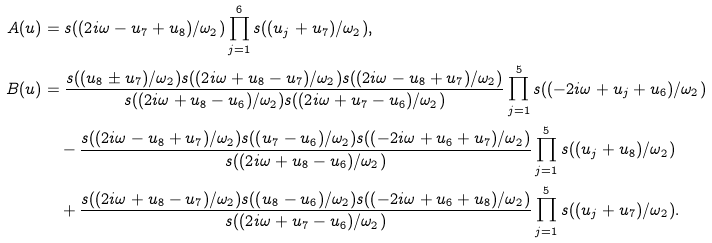Convert formula to latex. <formula><loc_0><loc_0><loc_500><loc_500>A ( u ) & = s ( ( 2 i \omega - u _ { 7 } + u _ { 8 } ) / \omega _ { 2 } ) \prod _ { j = 1 } ^ { 6 } s ( ( u _ { j } + u _ { 7 } ) / \omega _ { 2 } ) , \\ B ( u ) & = \frac { s ( ( u _ { 8 } \pm u _ { 7 } ) / \omega _ { 2 } ) s ( ( 2 i \omega + u _ { 8 } - u _ { 7 } ) / \omega _ { 2 } ) s ( ( 2 i \omega - u _ { 8 } + u _ { 7 } ) / \omega _ { 2 } ) } { s ( ( 2 i \omega + u _ { 8 } - u _ { 6 } ) / \omega _ { 2 } ) s ( ( 2 i \omega + u _ { 7 } - u _ { 6 } ) / \omega _ { 2 } ) } \prod _ { j = 1 } ^ { 5 } s ( ( - 2 i \omega + u _ { j } + u _ { 6 } ) / \omega _ { 2 } ) \\ & \quad - \frac { s ( ( 2 i \omega - u _ { 8 } + u _ { 7 } ) / \omega _ { 2 } ) s ( ( u _ { 7 } - u _ { 6 } ) / \omega _ { 2 } ) s ( ( - 2 i \omega + u _ { 6 } + u _ { 7 } ) / \omega _ { 2 } ) } { s ( ( 2 i \omega + u _ { 8 } - u _ { 6 } ) / \omega _ { 2 } ) } \prod _ { j = 1 } ^ { 5 } s ( ( u _ { j } + u _ { 8 } ) / \omega _ { 2 } ) \\ & \quad + \frac { s ( ( 2 i \omega + u _ { 8 } - u _ { 7 } ) / \omega _ { 2 } ) s ( ( u _ { 8 } - u _ { 6 } ) / \omega _ { 2 } ) s ( ( - 2 i \omega + u _ { 6 } + u _ { 8 } ) / \omega _ { 2 } ) } { s ( ( 2 i \omega + u _ { 7 } - u _ { 6 } ) / \omega _ { 2 } ) } \prod _ { j = 1 } ^ { 5 } s ( ( u _ { j } + u _ { 7 } ) / \omega _ { 2 } ) .</formula> 